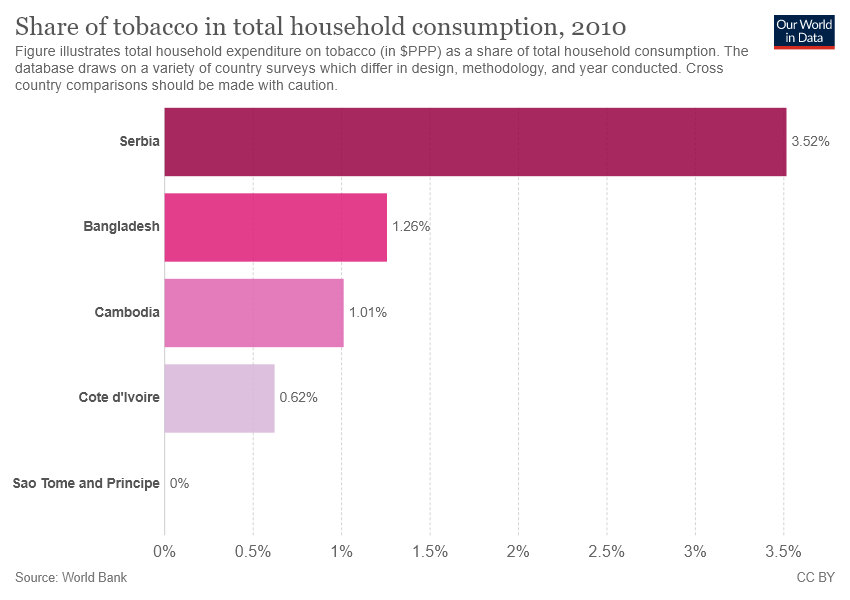Identify some key points in this picture. The value of the darkest purple bar is approximately 0.0352, with a notation indicating that it is a decimal number. The average of the two smallest bars is approximately 0.815. 